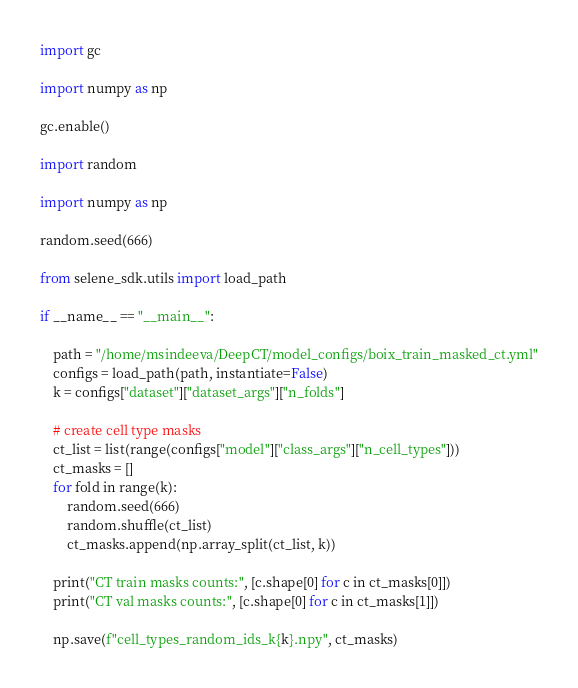Convert code to text. <code><loc_0><loc_0><loc_500><loc_500><_Python_>import gc

import numpy as np

gc.enable()

import random

import numpy as np

random.seed(666)

from selene_sdk.utils import load_path

if __name__ == "__main__":

    path = "/home/msindeeva/DeepCT/model_configs/boix_train_masked_ct.yml"
    configs = load_path(path, instantiate=False)
    k = configs["dataset"]["dataset_args"]["n_folds"]

    # create cell type masks
    ct_list = list(range(configs["model"]["class_args"]["n_cell_types"]))
    ct_masks = []
    for fold in range(k):
        random.seed(666)
        random.shuffle(ct_list)
        ct_masks.append(np.array_split(ct_list, k))

    print("CT train masks counts:", [c.shape[0] for c in ct_masks[0]])
    print("CT val masks counts:", [c.shape[0] for c in ct_masks[1]])

    np.save(f"cell_types_random_ids_k{k}.npy", ct_masks)
</code> 